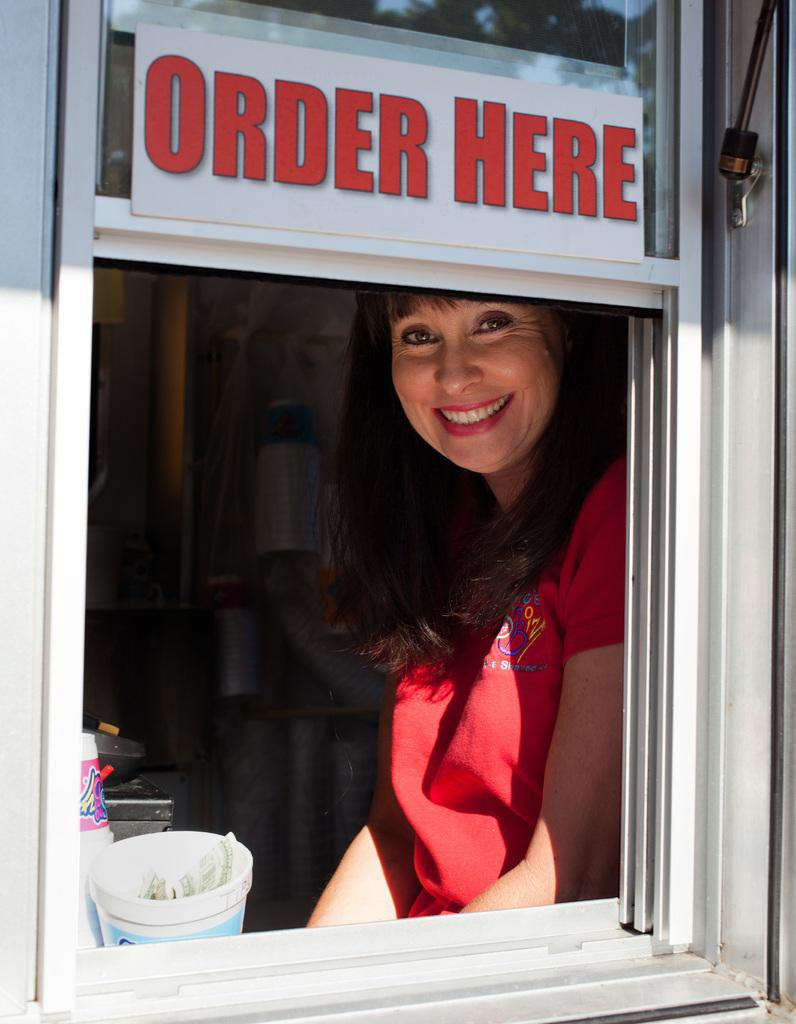What is the main feature of the window in the image? There is a board in the window in the image. How is the person in the image feeling? The person in the image is smiling. What can be seen in the background of the image? There are objects visible in the background of the image. Can you see a mitten being used to touch the board in the image? There is no mitten or any indication of touching the board in the image. What type of view can be seen through the window in the image? The provided facts do not mention any specific view through the window, so it cannot be determined from the image. 